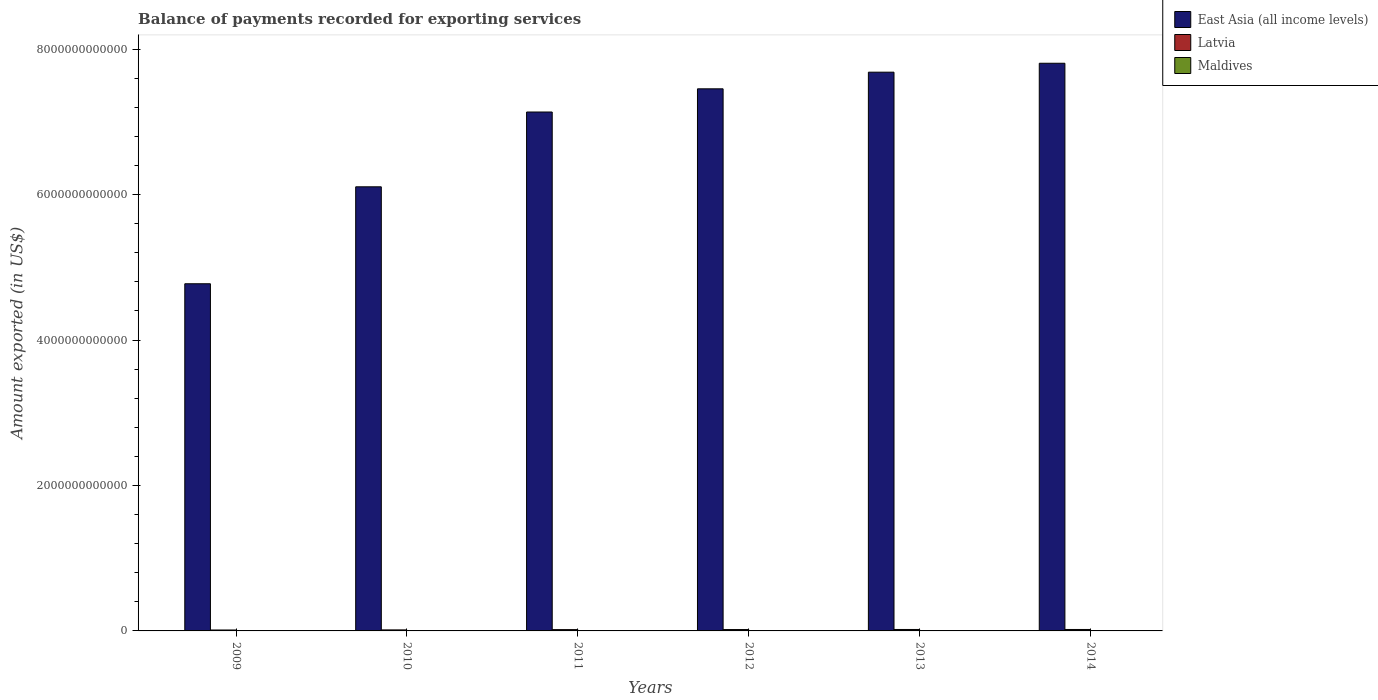How many bars are there on the 6th tick from the right?
Your answer should be very brief. 3. What is the label of the 1st group of bars from the left?
Give a very brief answer. 2009. In how many cases, is the number of bars for a given year not equal to the number of legend labels?
Ensure brevity in your answer.  0. What is the amount exported in East Asia (all income levels) in 2014?
Your response must be concise. 7.81e+12. Across all years, what is the maximum amount exported in East Asia (all income levels)?
Give a very brief answer. 7.81e+12. Across all years, what is the minimum amount exported in Latvia?
Offer a very short reply. 1.28e+1. In which year was the amount exported in Maldives maximum?
Keep it short and to the point. 2014. What is the total amount exported in East Asia (all income levels) in the graph?
Offer a terse response. 4.10e+13. What is the difference between the amount exported in Maldives in 2012 and that in 2013?
Your answer should be very brief. -4.31e+08. What is the difference between the amount exported in Maldives in 2011 and the amount exported in East Asia (all income levels) in 2009?
Provide a succinct answer. -4.77e+12. What is the average amount exported in Latvia per year?
Give a very brief answer. 1.73e+1. In the year 2013, what is the difference between the amount exported in Latvia and amount exported in Maldives?
Provide a succinct answer. 1.69e+1. In how many years, is the amount exported in Latvia greater than 7200000000000 US$?
Offer a terse response. 0. What is the ratio of the amount exported in Latvia in 2013 to that in 2014?
Offer a terse response. 0.99. Is the difference between the amount exported in Latvia in 2009 and 2014 greater than the difference between the amount exported in Maldives in 2009 and 2014?
Your response must be concise. No. What is the difference between the highest and the second highest amount exported in Latvia?
Provide a short and direct response. 1.13e+08. What is the difference between the highest and the lowest amount exported in Maldives?
Your answer should be very brief. 1.57e+09. What does the 2nd bar from the left in 2012 represents?
Your answer should be compact. Latvia. What does the 2nd bar from the right in 2012 represents?
Your answer should be compact. Latvia. Is it the case that in every year, the sum of the amount exported in Maldives and amount exported in East Asia (all income levels) is greater than the amount exported in Latvia?
Provide a short and direct response. Yes. How many bars are there?
Provide a succinct answer. 18. What is the difference between two consecutive major ticks on the Y-axis?
Provide a succinct answer. 2.00e+12. Does the graph contain any zero values?
Your response must be concise. No. Where does the legend appear in the graph?
Give a very brief answer. Top right. How many legend labels are there?
Provide a succinct answer. 3. How are the legend labels stacked?
Provide a short and direct response. Vertical. What is the title of the graph?
Keep it short and to the point. Balance of payments recorded for exporting services. What is the label or title of the Y-axis?
Give a very brief answer. Amount exported (in US$). What is the Amount exported (in US$) in East Asia (all income levels) in 2009?
Offer a very short reply. 4.77e+12. What is the Amount exported (in US$) of Latvia in 2009?
Ensure brevity in your answer.  1.28e+1. What is the Amount exported (in US$) of Maldives in 2009?
Provide a succinct answer. 1.72e+09. What is the Amount exported (in US$) in East Asia (all income levels) in 2010?
Your answer should be very brief. 6.11e+12. What is the Amount exported (in US$) in Latvia in 2010?
Provide a short and direct response. 1.41e+1. What is the Amount exported (in US$) of Maldives in 2010?
Keep it short and to the point. 2.01e+09. What is the Amount exported (in US$) of East Asia (all income levels) in 2011?
Your response must be concise. 7.14e+12. What is the Amount exported (in US$) of Latvia in 2011?
Provide a short and direct response. 1.79e+1. What is the Amount exported (in US$) in Maldives in 2011?
Keep it short and to the point. 2.46e+09. What is the Amount exported (in US$) of East Asia (all income levels) in 2012?
Offer a terse response. 7.45e+12. What is the Amount exported (in US$) in Latvia in 2012?
Your answer should be very brief. 1.88e+1. What is the Amount exported (in US$) of Maldives in 2012?
Provide a short and direct response. 2.50e+09. What is the Amount exported (in US$) in East Asia (all income levels) in 2013?
Your response must be concise. 7.68e+12. What is the Amount exported (in US$) of Latvia in 2013?
Give a very brief answer. 1.99e+1. What is the Amount exported (in US$) in Maldives in 2013?
Provide a succinct answer. 2.94e+09. What is the Amount exported (in US$) of East Asia (all income levels) in 2014?
Give a very brief answer. 7.81e+12. What is the Amount exported (in US$) of Latvia in 2014?
Make the answer very short. 2.00e+1. What is the Amount exported (in US$) in Maldives in 2014?
Give a very brief answer. 3.29e+09. Across all years, what is the maximum Amount exported (in US$) in East Asia (all income levels)?
Your answer should be compact. 7.81e+12. Across all years, what is the maximum Amount exported (in US$) in Latvia?
Offer a very short reply. 2.00e+1. Across all years, what is the maximum Amount exported (in US$) of Maldives?
Provide a succinct answer. 3.29e+09. Across all years, what is the minimum Amount exported (in US$) in East Asia (all income levels)?
Your answer should be very brief. 4.77e+12. Across all years, what is the minimum Amount exported (in US$) of Latvia?
Provide a short and direct response. 1.28e+1. Across all years, what is the minimum Amount exported (in US$) of Maldives?
Your response must be concise. 1.72e+09. What is the total Amount exported (in US$) in East Asia (all income levels) in the graph?
Your answer should be compact. 4.10e+13. What is the total Amount exported (in US$) in Latvia in the graph?
Your answer should be very brief. 1.04e+11. What is the total Amount exported (in US$) of Maldives in the graph?
Offer a very short reply. 1.49e+1. What is the difference between the Amount exported (in US$) of East Asia (all income levels) in 2009 and that in 2010?
Your response must be concise. -1.33e+12. What is the difference between the Amount exported (in US$) in Latvia in 2009 and that in 2010?
Give a very brief answer. -1.27e+09. What is the difference between the Amount exported (in US$) in Maldives in 2009 and that in 2010?
Make the answer very short. -2.93e+08. What is the difference between the Amount exported (in US$) in East Asia (all income levels) in 2009 and that in 2011?
Provide a succinct answer. -2.36e+12. What is the difference between the Amount exported (in US$) of Latvia in 2009 and that in 2011?
Your answer should be compact. -5.09e+09. What is the difference between the Amount exported (in US$) in Maldives in 2009 and that in 2011?
Keep it short and to the point. -7.41e+08. What is the difference between the Amount exported (in US$) in East Asia (all income levels) in 2009 and that in 2012?
Make the answer very short. -2.68e+12. What is the difference between the Amount exported (in US$) of Latvia in 2009 and that in 2012?
Your answer should be compact. -6.00e+09. What is the difference between the Amount exported (in US$) in Maldives in 2009 and that in 2012?
Provide a short and direct response. -7.86e+08. What is the difference between the Amount exported (in US$) in East Asia (all income levels) in 2009 and that in 2013?
Provide a succinct answer. -2.91e+12. What is the difference between the Amount exported (in US$) of Latvia in 2009 and that in 2013?
Make the answer very short. -7.01e+09. What is the difference between the Amount exported (in US$) of Maldives in 2009 and that in 2013?
Keep it short and to the point. -1.22e+09. What is the difference between the Amount exported (in US$) in East Asia (all income levels) in 2009 and that in 2014?
Ensure brevity in your answer.  -3.03e+12. What is the difference between the Amount exported (in US$) in Latvia in 2009 and that in 2014?
Your answer should be very brief. -7.13e+09. What is the difference between the Amount exported (in US$) in Maldives in 2009 and that in 2014?
Your answer should be compact. -1.57e+09. What is the difference between the Amount exported (in US$) in East Asia (all income levels) in 2010 and that in 2011?
Your answer should be very brief. -1.03e+12. What is the difference between the Amount exported (in US$) of Latvia in 2010 and that in 2011?
Your response must be concise. -3.82e+09. What is the difference between the Amount exported (in US$) of Maldives in 2010 and that in 2011?
Your answer should be compact. -4.48e+08. What is the difference between the Amount exported (in US$) of East Asia (all income levels) in 2010 and that in 2012?
Provide a succinct answer. -1.35e+12. What is the difference between the Amount exported (in US$) in Latvia in 2010 and that in 2012?
Provide a succinct answer. -4.73e+09. What is the difference between the Amount exported (in US$) in Maldives in 2010 and that in 2012?
Keep it short and to the point. -4.92e+08. What is the difference between the Amount exported (in US$) of East Asia (all income levels) in 2010 and that in 2013?
Offer a very short reply. -1.58e+12. What is the difference between the Amount exported (in US$) of Latvia in 2010 and that in 2013?
Keep it short and to the point. -5.75e+09. What is the difference between the Amount exported (in US$) of Maldives in 2010 and that in 2013?
Your answer should be compact. -9.24e+08. What is the difference between the Amount exported (in US$) of East Asia (all income levels) in 2010 and that in 2014?
Give a very brief answer. -1.70e+12. What is the difference between the Amount exported (in US$) in Latvia in 2010 and that in 2014?
Your answer should be compact. -5.86e+09. What is the difference between the Amount exported (in US$) in Maldives in 2010 and that in 2014?
Make the answer very short. -1.28e+09. What is the difference between the Amount exported (in US$) of East Asia (all income levels) in 2011 and that in 2012?
Offer a very short reply. -3.19e+11. What is the difference between the Amount exported (in US$) in Latvia in 2011 and that in 2012?
Your response must be concise. -9.16e+08. What is the difference between the Amount exported (in US$) of Maldives in 2011 and that in 2012?
Your answer should be compact. -4.47e+07. What is the difference between the Amount exported (in US$) in East Asia (all income levels) in 2011 and that in 2013?
Provide a short and direct response. -5.48e+11. What is the difference between the Amount exported (in US$) of Latvia in 2011 and that in 2013?
Give a very brief answer. -1.93e+09. What is the difference between the Amount exported (in US$) of Maldives in 2011 and that in 2013?
Your answer should be compact. -4.76e+08. What is the difference between the Amount exported (in US$) in East Asia (all income levels) in 2011 and that in 2014?
Offer a terse response. -6.70e+11. What is the difference between the Amount exported (in US$) of Latvia in 2011 and that in 2014?
Keep it short and to the point. -2.04e+09. What is the difference between the Amount exported (in US$) of Maldives in 2011 and that in 2014?
Give a very brief answer. -8.29e+08. What is the difference between the Amount exported (in US$) of East Asia (all income levels) in 2012 and that in 2013?
Your response must be concise. -2.29e+11. What is the difference between the Amount exported (in US$) of Latvia in 2012 and that in 2013?
Give a very brief answer. -1.01e+09. What is the difference between the Amount exported (in US$) in Maldives in 2012 and that in 2013?
Provide a short and direct response. -4.31e+08. What is the difference between the Amount exported (in US$) in East Asia (all income levels) in 2012 and that in 2014?
Your answer should be compact. -3.51e+11. What is the difference between the Amount exported (in US$) of Latvia in 2012 and that in 2014?
Provide a short and direct response. -1.13e+09. What is the difference between the Amount exported (in US$) in Maldives in 2012 and that in 2014?
Provide a short and direct response. -7.85e+08. What is the difference between the Amount exported (in US$) in East Asia (all income levels) in 2013 and that in 2014?
Your answer should be very brief. -1.23e+11. What is the difference between the Amount exported (in US$) of Latvia in 2013 and that in 2014?
Provide a succinct answer. -1.13e+08. What is the difference between the Amount exported (in US$) in Maldives in 2013 and that in 2014?
Your answer should be compact. -3.53e+08. What is the difference between the Amount exported (in US$) of East Asia (all income levels) in 2009 and the Amount exported (in US$) of Latvia in 2010?
Make the answer very short. 4.76e+12. What is the difference between the Amount exported (in US$) in East Asia (all income levels) in 2009 and the Amount exported (in US$) in Maldives in 2010?
Offer a terse response. 4.77e+12. What is the difference between the Amount exported (in US$) in Latvia in 2009 and the Amount exported (in US$) in Maldives in 2010?
Offer a very short reply. 1.08e+1. What is the difference between the Amount exported (in US$) in East Asia (all income levels) in 2009 and the Amount exported (in US$) in Latvia in 2011?
Offer a very short reply. 4.76e+12. What is the difference between the Amount exported (in US$) of East Asia (all income levels) in 2009 and the Amount exported (in US$) of Maldives in 2011?
Give a very brief answer. 4.77e+12. What is the difference between the Amount exported (in US$) in Latvia in 2009 and the Amount exported (in US$) in Maldives in 2011?
Provide a short and direct response. 1.04e+1. What is the difference between the Amount exported (in US$) in East Asia (all income levels) in 2009 and the Amount exported (in US$) in Latvia in 2012?
Provide a succinct answer. 4.75e+12. What is the difference between the Amount exported (in US$) in East Asia (all income levels) in 2009 and the Amount exported (in US$) in Maldives in 2012?
Your answer should be compact. 4.77e+12. What is the difference between the Amount exported (in US$) of Latvia in 2009 and the Amount exported (in US$) of Maldives in 2012?
Provide a succinct answer. 1.03e+1. What is the difference between the Amount exported (in US$) in East Asia (all income levels) in 2009 and the Amount exported (in US$) in Latvia in 2013?
Your response must be concise. 4.75e+12. What is the difference between the Amount exported (in US$) in East Asia (all income levels) in 2009 and the Amount exported (in US$) in Maldives in 2013?
Make the answer very short. 4.77e+12. What is the difference between the Amount exported (in US$) in Latvia in 2009 and the Amount exported (in US$) in Maldives in 2013?
Your answer should be compact. 9.91e+09. What is the difference between the Amount exported (in US$) of East Asia (all income levels) in 2009 and the Amount exported (in US$) of Latvia in 2014?
Make the answer very short. 4.75e+12. What is the difference between the Amount exported (in US$) in East Asia (all income levels) in 2009 and the Amount exported (in US$) in Maldives in 2014?
Keep it short and to the point. 4.77e+12. What is the difference between the Amount exported (in US$) in Latvia in 2009 and the Amount exported (in US$) in Maldives in 2014?
Offer a terse response. 9.56e+09. What is the difference between the Amount exported (in US$) in East Asia (all income levels) in 2010 and the Amount exported (in US$) in Latvia in 2011?
Give a very brief answer. 6.09e+12. What is the difference between the Amount exported (in US$) of East Asia (all income levels) in 2010 and the Amount exported (in US$) of Maldives in 2011?
Your answer should be compact. 6.10e+12. What is the difference between the Amount exported (in US$) in Latvia in 2010 and the Amount exported (in US$) in Maldives in 2011?
Give a very brief answer. 1.17e+1. What is the difference between the Amount exported (in US$) in East Asia (all income levels) in 2010 and the Amount exported (in US$) in Latvia in 2012?
Your answer should be compact. 6.09e+12. What is the difference between the Amount exported (in US$) of East Asia (all income levels) in 2010 and the Amount exported (in US$) of Maldives in 2012?
Your answer should be compact. 6.10e+12. What is the difference between the Amount exported (in US$) in Latvia in 2010 and the Amount exported (in US$) in Maldives in 2012?
Ensure brevity in your answer.  1.16e+1. What is the difference between the Amount exported (in US$) of East Asia (all income levels) in 2010 and the Amount exported (in US$) of Latvia in 2013?
Your response must be concise. 6.09e+12. What is the difference between the Amount exported (in US$) in East Asia (all income levels) in 2010 and the Amount exported (in US$) in Maldives in 2013?
Keep it short and to the point. 6.10e+12. What is the difference between the Amount exported (in US$) of Latvia in 2010 and the Amount exported (in US$) of Maldives in 2013?
Make the answer very short. 1.12e+1. What is the difference between the Amount exported (in US$) in East Asia (all income levels) in 2010 and the Amount exported (in US$) in Latvia in 2014?
Offer a terse response. 6.09e+12. What is the difference between the Amount exported (in US$) of East Asia (all income levels) in 2010 and the Amount exported (in US$) of Maldives in 2014?
Your answer should be very brief. 6.10e+12. What is the difference between the Amount exported (in US$) of Latvia in 2010 and the Amount exported (in US$) of Maldives in 2014?
Ensure brevity in your answer.  1.08e+1. What is the difference between the Amount exported (in US$) of East Asia (all income levels) in 2011 and the Amount exported (in US$) of Latvia in 2012?
Ensure brevity in your answer.  7.12e+12. What is the difference between the Amount exported (in US$) of East Asia (all income levels) in 2011 and the Amount exported (in US$) of Maldives in 2012?
Make the answer very short. 7.13e+12. What is the difference between the Amount exported (in US$) of Latvia in 2011 and the Amount exported (in US$) of Maldives in 2012?
Your answer should be compact. 1.54e+1. What is the difference between the Amount exported (in US$) in East Asia (all income levels) in 2011 and the Amount exported (in US$) in Latvia in 2013?
Your answer should be compact. 7.12e+12. What is the difference between the Amount exported (in US$) of East Asia (all income levels) in 2011 and the Amount exported (in US$) of Maldives in 2013?
Provide a short and direct response. 7.13e+12. What is the difference between the Amount exported (in US$) of Latvia in 2011 and the Amount exported (in US$) of Maldives in 2013?
Your response must be concise. 1.50e+1. What is the difference between the Amount exported (in US$) of East Asia (all income levels) in 2011 and the Amount exported (in US$) of Latvia in 2014?
Make the answer very short. 7.12e+12. What is the difference between the Amount exported (in US$) of East Asia (all income levels) in 2011 and the Amount exported (in US$) of Maldives in 2014?
Your answer should be very brief. 7.13e+12. What is the difference between the Amount exported (in US$) of Latvia in 2011 and the Amount exported (in US$) of Maldives in 2014?
Ensure brevity in your answer.  1.46e+1. What is the difference between the Amount exported (in US$) in East Asia (all income levels) in 2012 and the Amount exported (in US$) in Latvia in 2013?
Offer a terse response. 7.43e+12. What is the difference between the Amount exported (in US$) in East Asia (all income levels) in 2012 and the Amount exported (in US$) in Maldives in 2013?
Your answer should be very brief. 7.45e+12. What is the difference between the Amount exported (in US$) of Latvia in 2012 and the Amount exported (in US$) of Maldives in 2013?
Make the answer very short. 1.59e+1. What is the difference between the Amount exported (in US$) of East Asia (all income levels) in 2012 and the Amount exported (in US$) of Latvia in 2014?
Provide a short and direct response. 7.43e+12. What is the difference between the Amount exported (in US$) in East Asia (all income levels) in 2012 and the Amount exported (in US$) in Maldives in 2014?
Provide a short and direct response. 7.45e+12. What is the difference between the Amount exported (in US$) in Latvia in 2012 and the Amount exported (in US$) in Maldives in 2014?
Offer a very short reply. 1.56e+1. What is the difference between the Amount exported (in US$) of East Asia (all income levels) in 2013 and the Amount exported (in US$) of Latvia in 2014?
Your response must be concise. 7.66e+12. What is the difference between the Amount exported (in US$) of East Asia (all income levels) in 2013 and the Amount exported (in US$) of Maldives in 2014?
Provide a short and direct response. 7.68e+12. What is the difference between the Amount exported (in US$) in Latvia in 2013 and the Amount exported (in US$) in Maldives in 2014?
Offer a very short reply. 1.66e+1. What is the average Amount exported (in US$) of East Asia (all income levels) per year?
Offer a terse response. 6.83e+12. What is the average Amount exported (in US$) in Latvia per year?
Give a very brief answer. 1.73e+1. What is the average Amount exported (in US$) in Maldives per year?
Your answer should be very brief. 2.49e+09. In the year 2009, what is the difference between the Amount exported (in US$) in East Asia (all income levels) and Amount exported (in US$) in Latvia?
Offer a terse response. 4.76e+12. In the year 2009, what is the difference between the Amount exported (in US$) of East Asia (all income levels) and Amount exported (in US$) of Maldives?
Make the answer very short. 4.77e+12. In the year 2009, what is the difference between the Amount exported (in US$) of Latvia and Amount exported (in US$) of Maldives?
Ensure brevity in your answer.  1.11e+1. In the year 2010, what is the difference between the Amount exported (in US$) in East Asia (all income levels) and Amount exported (in US$) in Latvia?
Provide a succinct answer. 6.09e+12. In the year 2010, what is the difference between the Amount exported (in US$) in East Asia (all income levels) and Amount exported (in US$) in Maldives?
Offer a terse response. 6.10e+12. In the year 2010, what is the difference between the Amount exported (in US$) of Latvia and Amount exported (in US$) of Maldives?
Provide a succinct answer. 1.21e+1. In the year 2011, what is the difference between the Amount exported (in US$) of East Asia (all income levels) and Amount exported (in US$) of Latvia?
Keep it short and to the point. 7.12e+12. In the year 2011, what is the difference between the Amount exported (in US$) in East Asia (all income levels) and Amount exported (in US$) in Maldives?
Your response must be concise. 7.13e+12. In the year 2011, what is the difference between the Amount exported (in US$) of Latvia and Amount exported (in US$) of Maldives?
Provide a short and direct response. 1.55e+1. In the year 2012, what is the difference between the Amount exported (in US$) of East Asia (all income levels) and Amount exported (in US$) of Latvia?
Provide a short and direct response. 7.44e+12. In the year 2012, what is the difference between the Amount exported (in US$) in East Asia (all income levels) and Amount exported (in US$) in Maldives?
Ensure brevity in your answer.  7.45e+12. In the year 2012, what is the difference between the Amount exported (in US$) of Latvia and Amount exported (in US$) of Maldives?
Offer a very short reply. 1.63e+1. In the year 2013, what is the difference between the Amount exported (in US$) of East Asia (all income levels) and Amount exported (in US$) of Latvia?
Your answer should be very brief. 7.66e+12. In the year 2013, what is the difference between the Amount exported (in US$) of East Asia (all income levels) and Amount exported (in US$) of Maldives?
Offer a terse response. 7.68e+12. In the year 2013, what is the difference between the Amount exported (in US$) in Latvia and Amount exported (in US$) in Maldives?
Offer a terse response. 1.69e+1. In the year 2014, what is the difference between the Amount exported (in US$) in East Asia (all income levels) and Amount exported (in US$) in Latvia?
Offer a terse response. 7.79e+12. In the year 2014, what is the difference between the Amount exported (in US$) of East Asia (all income levels) and Amount exported (in US$) of Maldives?
Offer a very short reply. 7.80e+12. In the year 2014, what is the difference between the Amount exported (in US$) of Latvia and Amount exported (in US$) of Maldives?
Make the answer very short. 1.67e+1. What is the ratio of the Amount exported (in US$) of East Asia (all income levels) in 2009 to that in 2010?
Make the answer very short. 0.78. What is the ratio of the Amount exported (in US$) in Latvia in 2009 to that in 2010?
Your answer should be compact. 0.91. What is the ratio of the Amount exported (in US$) in Maldives in 2009 to that in 2010?
Keep it short and to the point. 0.85. What is the ratio of the Amount exported (in US$) in East Asia (all income levels) in 2009 to that in 2011?
Provide a succinct answer. 0.67. What is the ratio of the Amount exported (in US$) in Latvia in 2009 to that in 2011?
Your answer should be very brief. 0.72. What is the ratio of the Amount exported (in US$) of Maldives in 2009 to that in 2011?
Offer a very short reply. 0.7. What is the ratio of the Amount exported (in US$) of East Asia (all income levels) in 2009 to that in 2012?
Provide a succinct answer. 0.64. What is the ratio of the Amount exported (in US$) of Latvia in 2009 to that in 2012?
Give a very brief answer. 0.68. What is the ratio of the Amount exported (in US$) in Maldives in 2009 to that in 2012?
Your answer should be compact. 0.69. What is the ratio of the Amount exported (in US$) of East Asia (all income levels) in 2009 to that in 2013?
Ensure brevity in your answer.  0.62. What is the ratio of the Amount exported (in US$) of Latvia in 2009 to that in 2013?
Make the answer very short. 0.65. What is the ratio of the Amount exported (in US$) of Maldives in 2009 to that in 2013?
Make the answer very short. 0.59. What is the ratio of the Amount exported (in US$) of East Asia (all income levels) in 2009 to that in 2014?
Provide a succinct answer. 0.61. What is the ratio of the Amount exported (in US$) in Latvia in 2009 to that in 2014?
Your answer should be compact. 0.64. What is the ratio of the Amount exported (in US$) of Maldives in 2009 to that in 2014?
Your answer should be compact. 0.52. What is the ratio of the Amount exported (in US$) of East Asia (all income levels) in 2010 to that in 2011?
Give a very brief answer. 0.86. What is the ratio of the Amount exported (in US$) of Latvia in 2010 to that in 2011?
Keep it short and to the point. 0.79. What is the ratio of the Amount exported (in US$) of Maldives in 2010 to that in 2011?
Your answer should be compact. 0.82. What is the ratio of the Amount exported (in US$) of East Asia (all income levels) in 2010 to that in 2012?
Offer a very short reply. 0.82. What is the ratio of the Amount exported (in US$) of Latvia in 2010 to that in 2012?
Provide a succinct answer. 0.75. What is the ratio of the Amount exported (in US$) in Maldives in 2010 to that in 2012?
Give a very brief answer. 0.8. What is the ratio of the Amount exported (in US$) of East Asia (all income levels) in 2010 to that in 2013?
Your answer should be very brief. 0.79. What is the ratio of the Amount exported (in US$) of Latvia in 2010 to that in 2013?
Your answer should be compact. 0.71. What is the ratio of the Amount exported (in US$) of Maldives in 2010 to that in 2013?
Your answer should be very brief. 0.69. What is the ratio of the Amount exported (in US$) of East Asia (all income levels) in 2010 to that in 2014?
Your answer should be very brief. 0.78. What is the ratio of the Amount exported (in US$) of Latvia in 2010 to that in 2014?
Your answer should be very brief. 0.71. What is the ratio of the Amount exported (in US$) of Maldives in 2010 to that in 2014?
Keep it short and to the point. 0.61. What is the ratio of the Amount exported (in US$) of East Asia (all income levels) in 2011 to that in 2012?
Your response must be concise. 0.96. What is the ratio of the Amount exported (in US$) of Latvia in 2011 to that in 2012?
Provide a succinct answer. 0.95. What is the ratio of the Amount exported (in US$) in Maldives in 2011 to that in 2012?
Provide a succinct answer. 0.98. What is the ratio of the Amount exported (in US$) of East Asia (all income levels) in 2011 to that in 2013?
Your answer should be very brief. 0.93. What is the ratio of the Amount exported (in US$) of Latvia in 2011 to that in 2013?
Make the answer very short. 0.9. What is the ratio of the Amount exported (in US$) of Maldives in 2011 to that in 2013?
Provide a short and direct response. 0.84. What is the ratio of the Amount exported (in US$) of East Asia (all income levels) in 2011 to that in 2014?
Your response must be concise. 0.91. What is the ratio of the Amount exported (in US$) in Latvia in 2011 to that in 2014?
Your answer should be very brief. 0.9. What is the ratio of the Amount exported (in US$) of Maldives in 2011 to that in 2014?
Keep it short and to the point. 0.75. What is the ratio of the Amount exported (in US$) in East Asia (all income levels) in 2012 to that in 2013?
Your answer should be very brief. 0.97. What is the ratio of the Amount exported (in US$) of Latvia in 2012 to that in 2013?
Your response must be concise. 0.95. What is the ratio of the Amount exported (in US$) in Maldives in 2012 to that in 2013?
Provide a short and direct response. 0.85. What is the ratio of the Amount exported (in US$) of East Asia (all income levels) in 2012 to that in 2014?
Provide a short and direct response. 0.95. What is the ratio of the Amount exported (in US$) of Latvia in 2012 to that in 2014?
Your response must be concise. 0.94. What is the ratio of the Amount exported (in US$) in Maldives in 2012 to that in 2014?
Your answer should be compact. 0.76. What is the ratio of the Amount exported (in US$) in East Asia (all income levels) in 2013 to that in 2014?
Provide a short and direct response. 0.98. What is the ratio of the Amount exported (in US$) of Latvia in 2013 to that in 2014?
Keep it short and to the point. 0.99. What is the ratio of the Amount exported (in US$) of Maldives in 2013 to that in 2014?
Keep it short and to the point. 0.89. What is the difference between the highest and the second highest Amount exported (in US$) of East Asia (all income levels)?
Your response must be concise. 1.23e+11. What is the difference between the highest and the second highest Amount exported (in US$) of Latvia?
Make the answer very short. 1.13e+08. What is the difference between the highest and the second highest Amount exported (in US$) of Maldives?
Your answer should be compact. 3.53e+08. What is the difference between the highest and the lowest Amount exported (in US$) of East Asia (all income levels)?
Your response must be concise. 3.03e+12. What is the difference between the highest and the lowest Amount exported (in US$) of Latvia?
Provide a succinct answer. 7.13e+09. What is the difference between the highest and the lowest Amount exported (in US$) of Maldives?
Your answer should be very brief. 1.57e+09. 